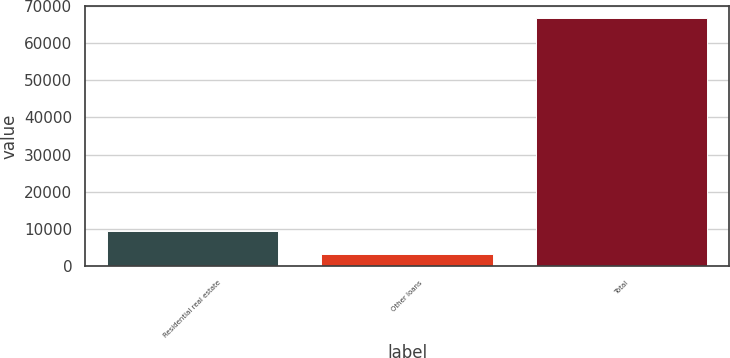Convert chart to OTSL. <chart><loc_0><loc_0><loc_500><loc_500><bar_chart><fcel>Residential real estate<fcel>Other loans<fcel>Total<nl><fcel>9610.3<fcel>3263<fcel>66736<nl></chart> 